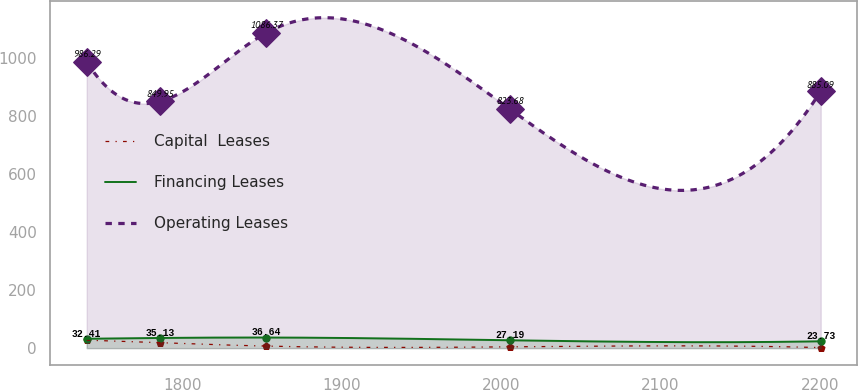<chart> <loc_0><loc_0><loc_500><loc_500><line_chart><ecel><fcel>Capital  Leases<fcel>Financing Leases<fcel>Operating Leases<nl><fcel>1740.02<fcel>27.53<fcel>32.41<fcel>986.29<nl><fcel>1786.06<fcel>18.73<fcel>35.13<fcel>849.95<nl><fcel>1852.71<fcel>7.13<fcel>36.64<fcel>1086.37<nl><fcel>2005.42<fcel>4.49<fcel>27.19<fcel>823.68<nl><fcel>2200.44<fcel>1.93<fcel>23.73<fcel>885.09<nl></chart> 